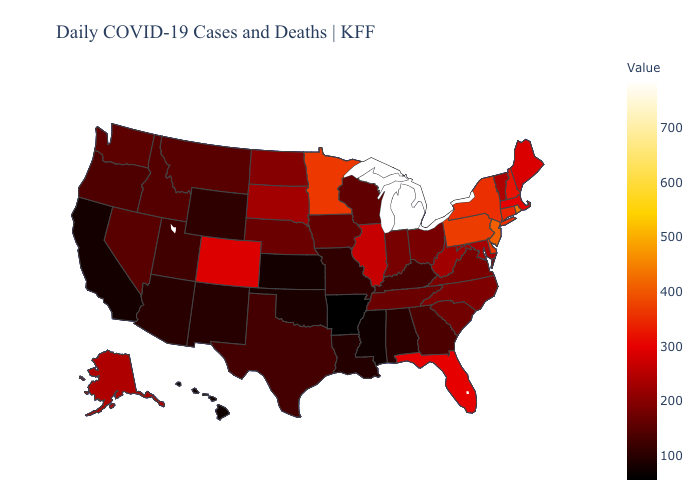Does Vermont have the lowest value in the Northeast?
Keep it brief. Yes. Among the states that border Wyoming , which have the highest value?
Give a very brief answer. Colorado. Among the states that border Pennsylvania , which have the highest value?
Concise answer only. New Jersey. Which states have the lowest value in the West?
Short answer required. Hawaii. Among the states that border Tennessee , does Arkansas have the lowest value?
Quick response, please. Yes. 